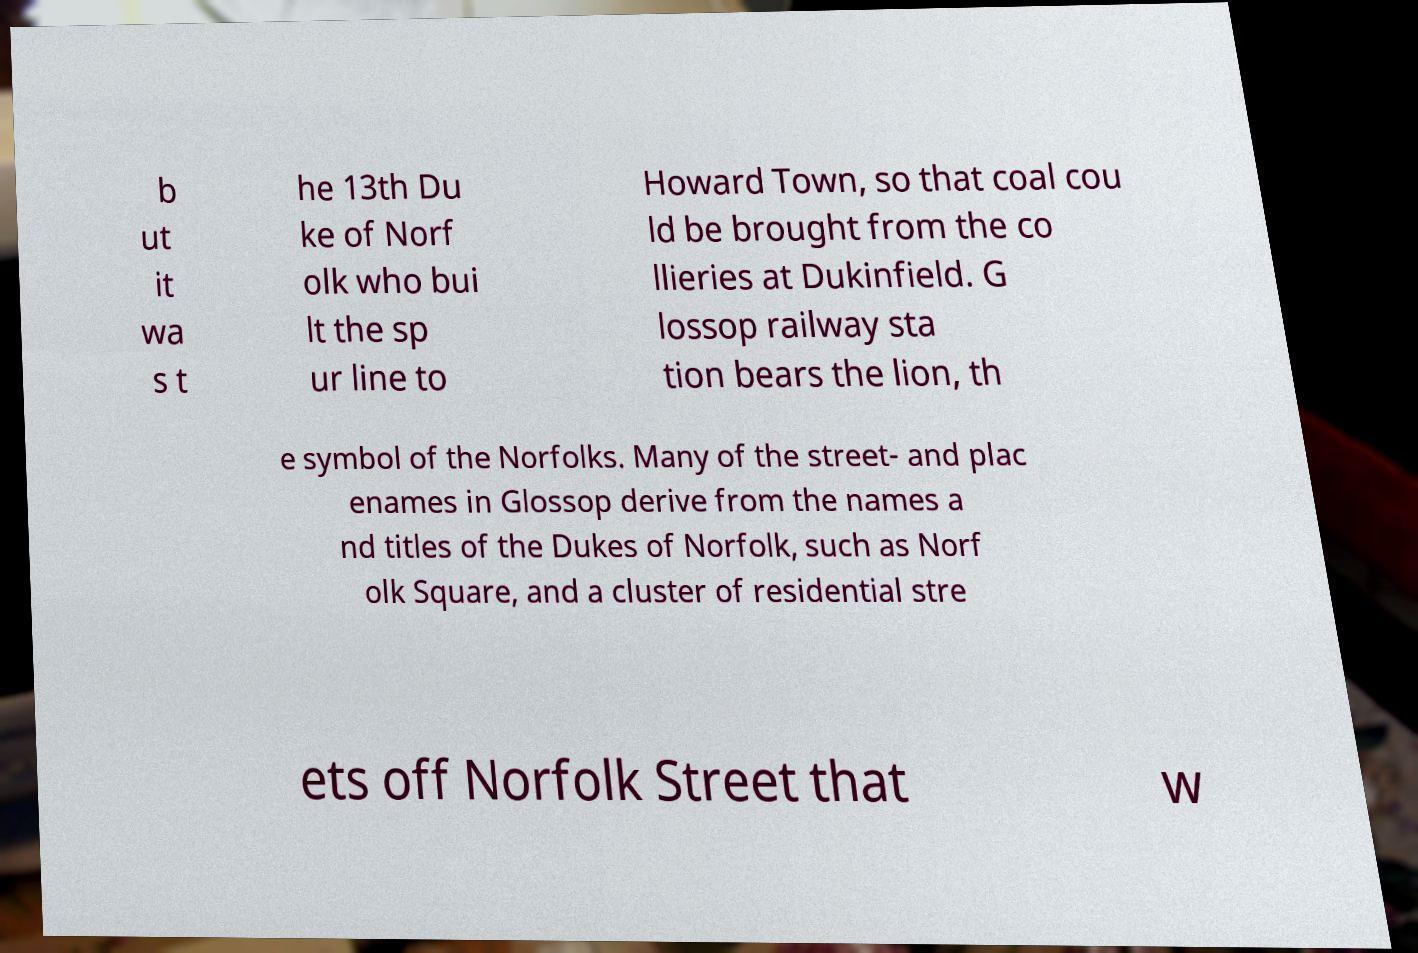What messages or text are displayed in this image? I need them in a readable, typed format. b ut it wa s t he 13th Du ke of Norf olk who bui lt the sp ur line to Howard Town, so that coal cou ld be brought from the co llieries at Dukinfield. G lossop railway sta tion bears the lion, th e symbol of the Norfolks. Many of the street- and plac enames in Glossop derive from the names a nd titles of the Dukes of Norfolk, such as Norf olk Square, and a cluster of residential stre ets off Norfolk Street that w 